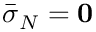Convert formula to latex. <formula><loc_0><loc_0><loc_500><loc_500>\bar { \sigma } _ { N } = { 0 }</formula> 